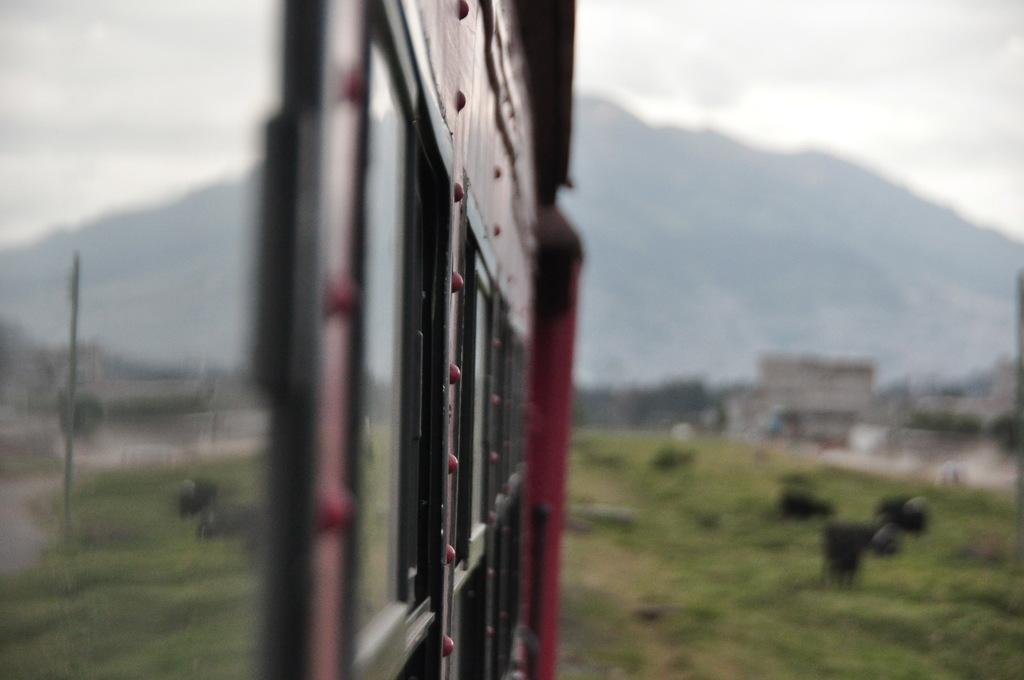What structure can be seen in the image? There is a gate in the image. What is happening near the gate? There are animals visible in the image, and they are eating grass. What can be seen in the distance in the image? There are mountains in the background of the image. How many quarters are needed to pay for the animals' journey in the image? There is no indication of a journey or payment in the image; it simply shows animals eating grass near a gate with mountains in the background. 